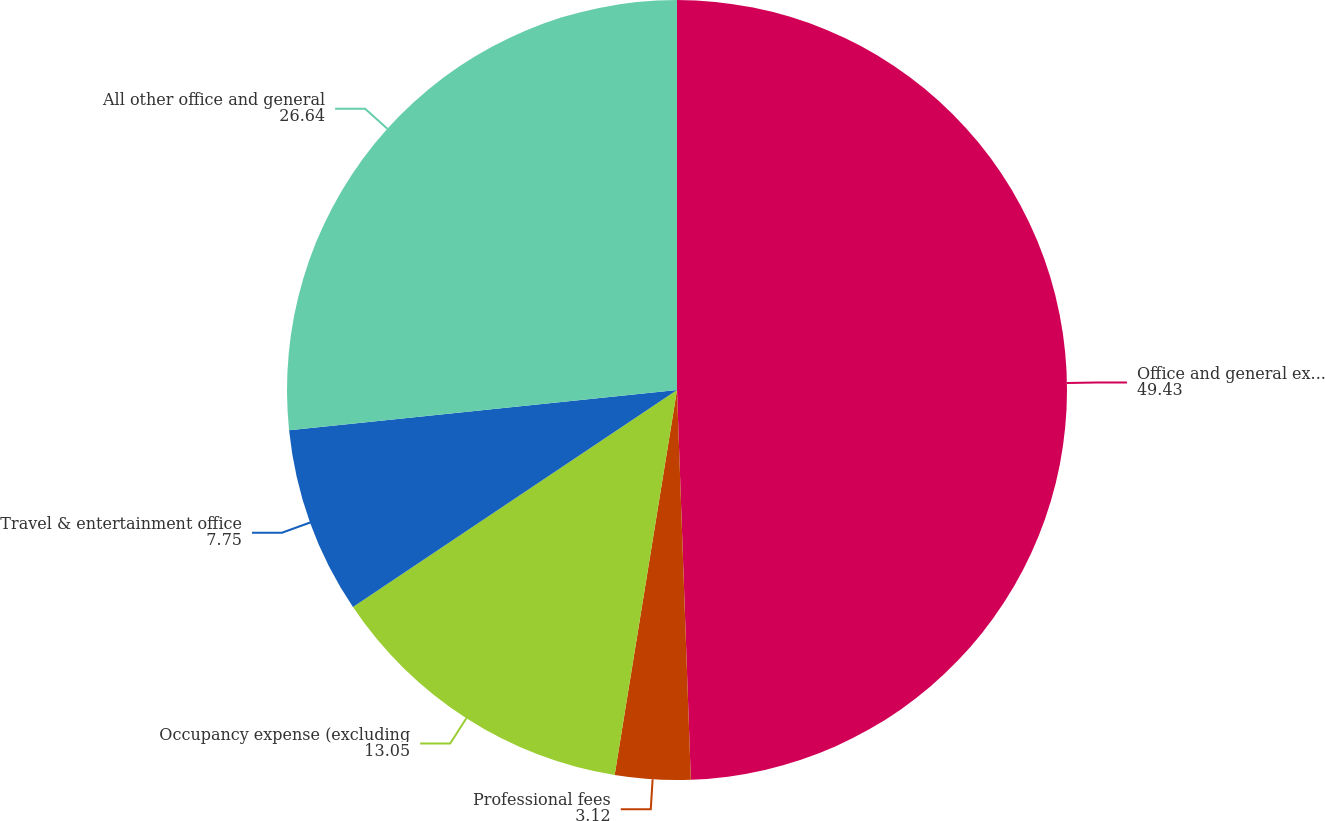Convert chart. <chart><loc_0><loc_0><loc_500><loc_500><pie_chart><fcel>Office and general expenses<fcel>Professional fees<fcel>Occupancy expense (excluding<fcel>Travel & entertainment office<fcel>All other office and general<nl><fcel>49.43%<fcel>3.12%<fcel>13.05%<fcel>7.75%<fcel>26.64%<nl></chart> 